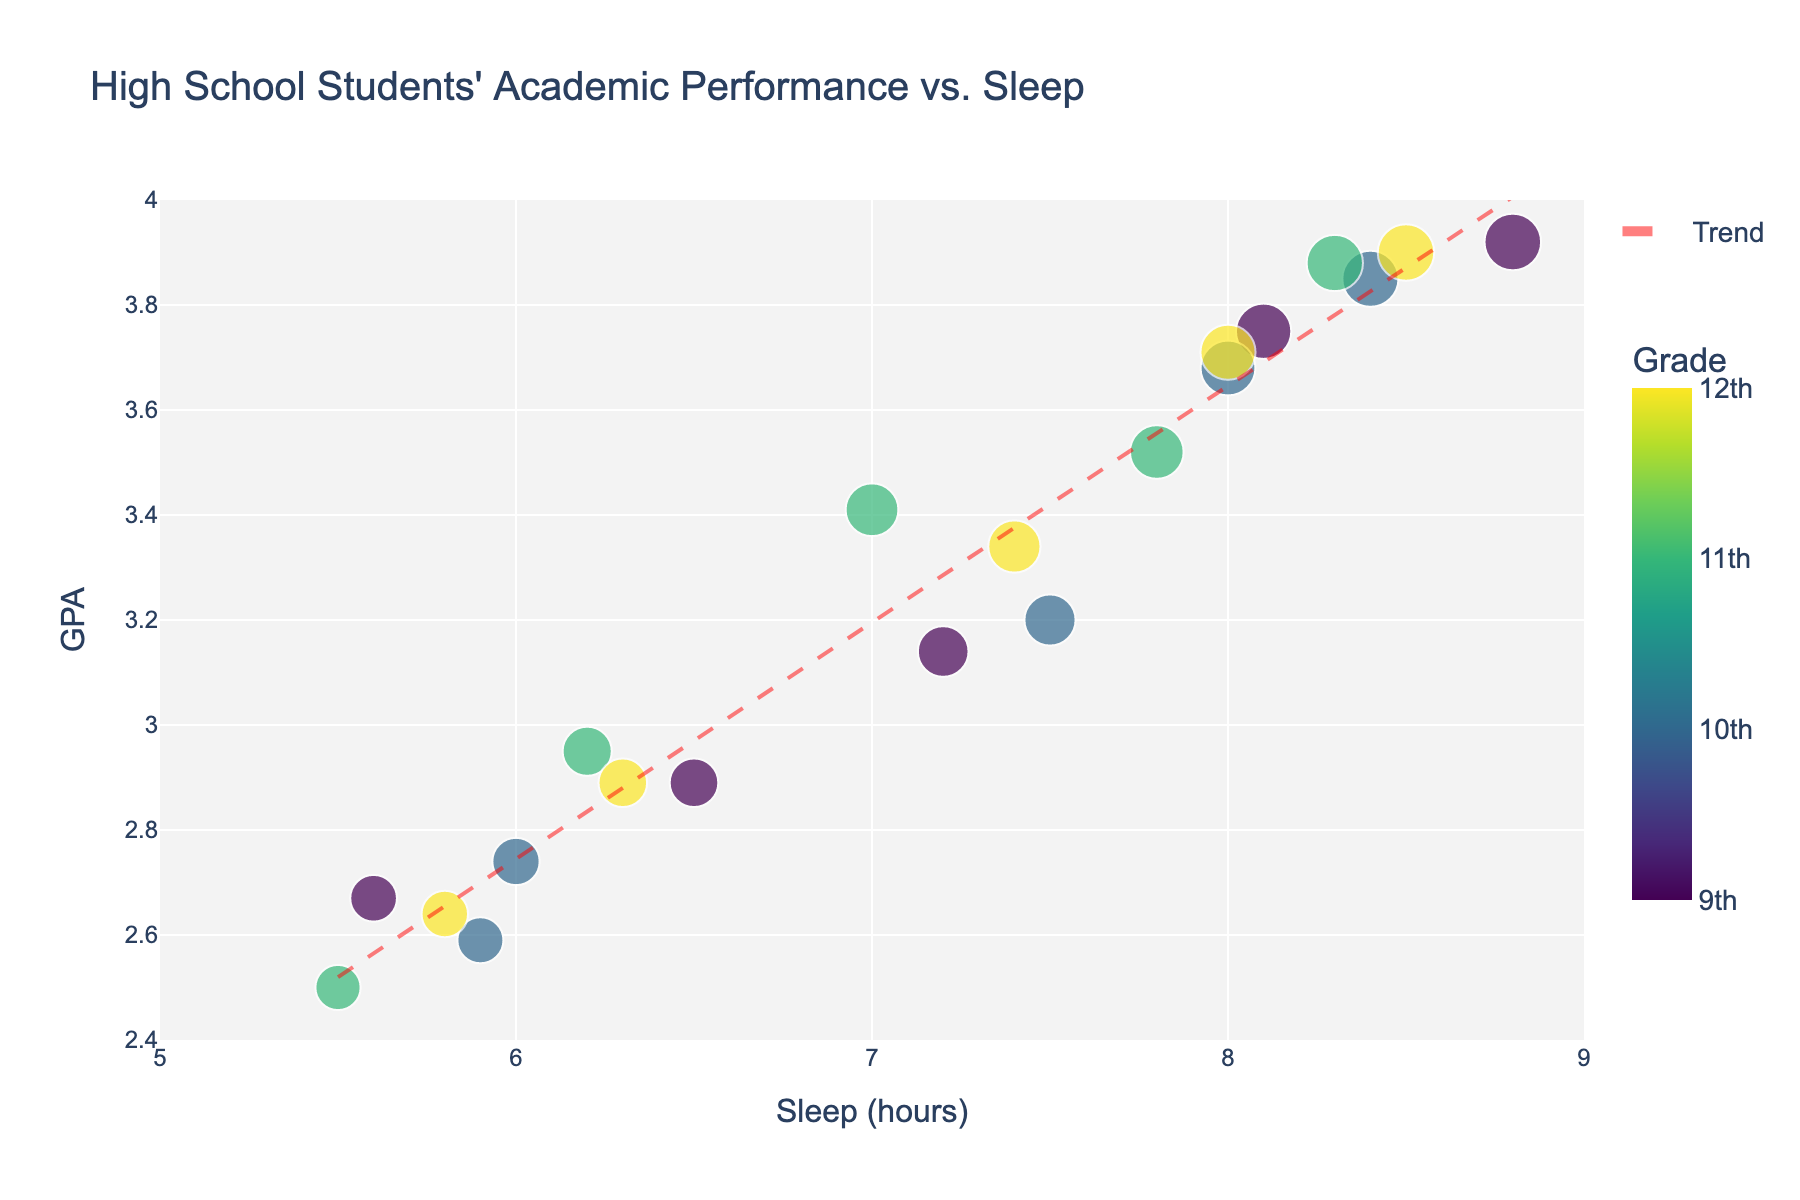What is the title of the plot? The title of the plot is shown at the top and provides a high-level summary of the figure. Reading the title can help understand what the plot represents.
Answer: High School Students' Academic Performance vs. Sleep How many data points are shown for 9th grade students? The color of the data points indicates the grade level, and we can count the number of points labeled with "9" in the Grade Level hover data.
Answer: 5 What is the range of the x-axis in the plot? Observing the ticks on the x-axis tells us the lower and upper bounds that are labeled—these provide the range.
Answer: 5 to 9 hours What is the average GPA of the 12th graders? To find the average GPA for 12th graders, identify all data points labeled "12" and then calculate the average of their GPA values. We sum the GPAs of the 5 data points (3.34 + 2.89 + 3.71 + 3.90 + 2.64) before dividing by 5. The calculation steps are: 3.34 + 2.89 + 3.71 + 3.90 + 2.64 = 16.48; 16.48 / 5 = 3.296.
Answer: 3.30 Which grade level shows the highest GPA in the plot? By examining the y-axis and identifying the data point at the highest position, then checking the color or hover data of that point, we can determine the grade level.
Answer: 9th grade Which grade level has the most data points? By counting the number of data points for each color/grade level, we can determine which has the most.
Answer: 9th grade What is the general trend shown by the trend line? Observing the direction of the trend line, which is added to the figure to indicate the overall relationship between hours of sleep and GPA, helps identify whether the trend is positive or negative.
Answer: Positive How does the GPA change when students get less than six hours of sleep? Refer to the x-axis to identify data points where the average hours of sleep are less than six, and then compare the GPA values of those points to observe the change.
Answer: GPA is generally lower What is the GPA for the student in 10th grade with the highest number of sleep hours? Identify the data point with the highest x-axis value among those labeled with "10" and then read off the corresponding GPA from the y-axis or hover data.
Answer: 3.85 How does the amount of sleep correlate with the GPA for 11th graders? By examining the positions of the data points for 11th grade students and observing whether higher sleep hours tend to be associated with higher GPA values, the correlation can be deduced.
Answer: Positive correlation 